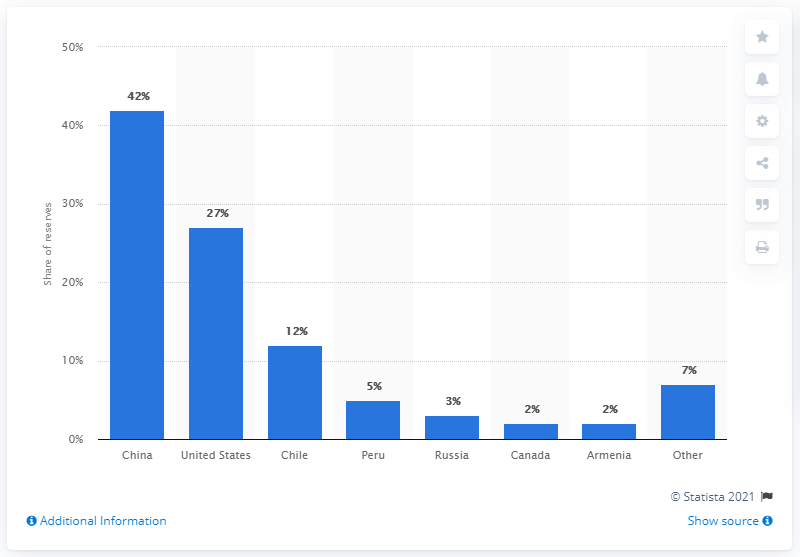Which country had the largest molybdenum reserves in 2016?
 China 